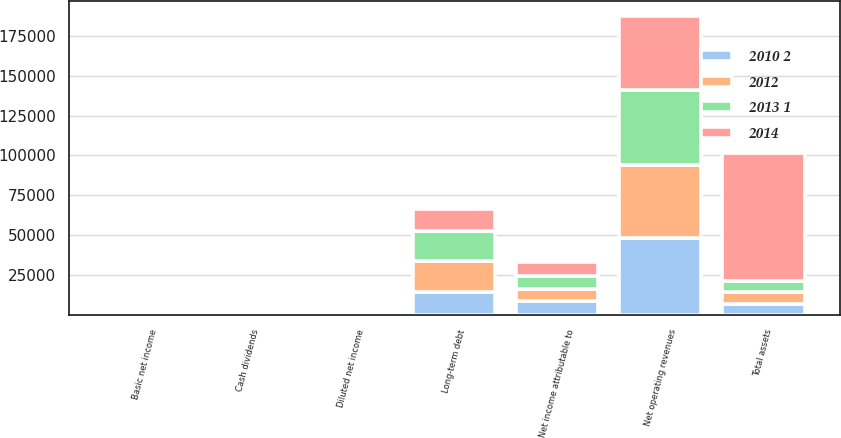Convert chart. <chart><loc_0><loc_0><loc_500><loc_500><stacked_bar_chart><ecel><fcel>Net operating revenues<fcel>Net income attributable to<fcel>Basic net income<fcel>Diluted net income<fcel>Cash dividends<fcel>Total assets<fcel>Long-term debt<nl><fcel>2012<fcel>45998<fcel>7098<fcel>1.62<fcel>1.6<fcel>1.22<fcel>7098<fcel>19063<nl><fcel>2013 1<fcel>46854<fcel>8584<fcel>1.94<fcel>1.9<fcel>1.12<fcel>7098<fcel>19154<nl><fcel>2010 2<fcel>48017<fcel>9019<fcel>2<fcel>1.97<fcel>1.02<fcel>7098<fcel>14736<nl><fcel>2014<fcel>46542<fcel>8584<fcel>1.88<fcel>1.85<fcel>0.94<fcel>79974<fcel>13656<nl></chart> 